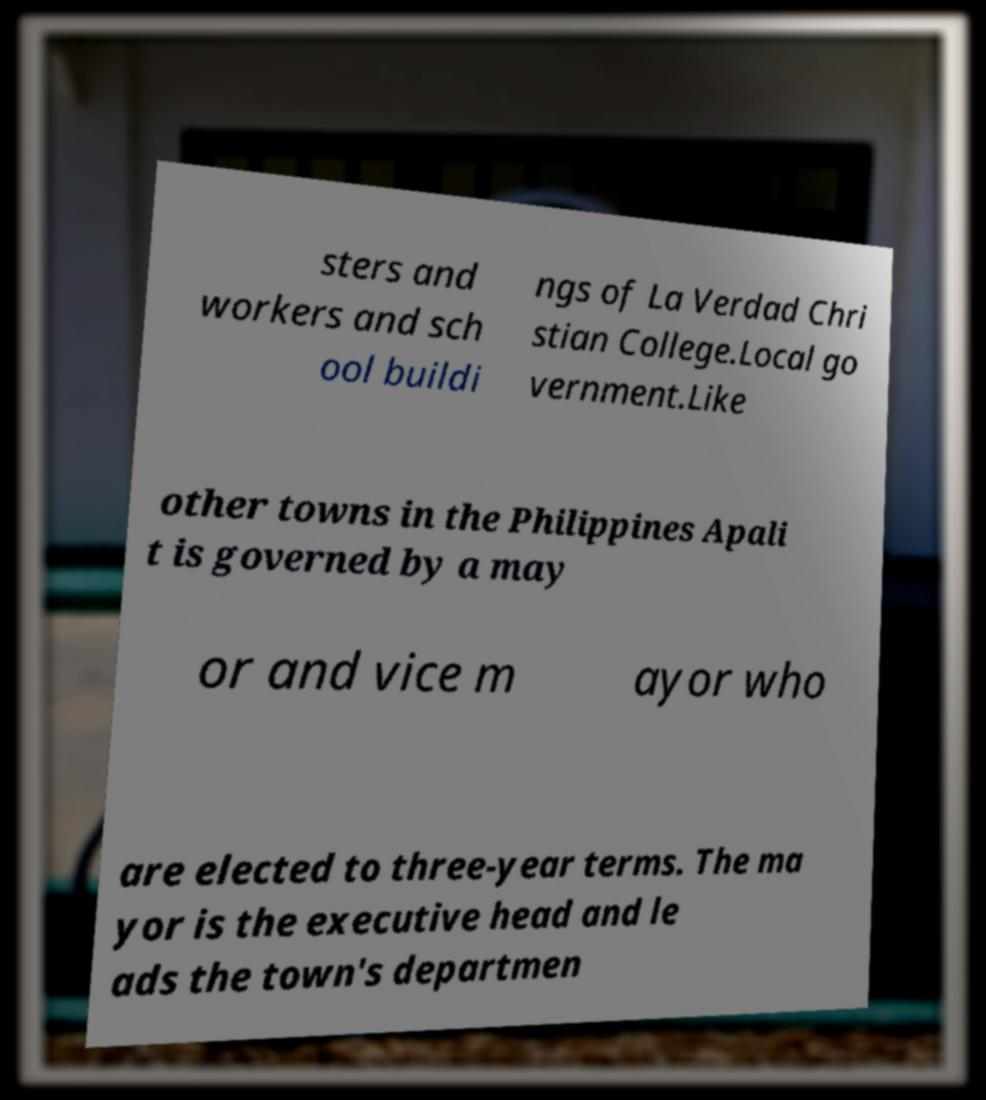Please identify and transcribe the text found in this image. sters and workers and sch ool buildi ngs of La Verdad Chri stian College.Local go vernment.Like other towns in the Philippines Apali t is governed by a may or and vice m ayor who are elected to three-year terms. The ma yor is the executive head and le ads the town's departmen 